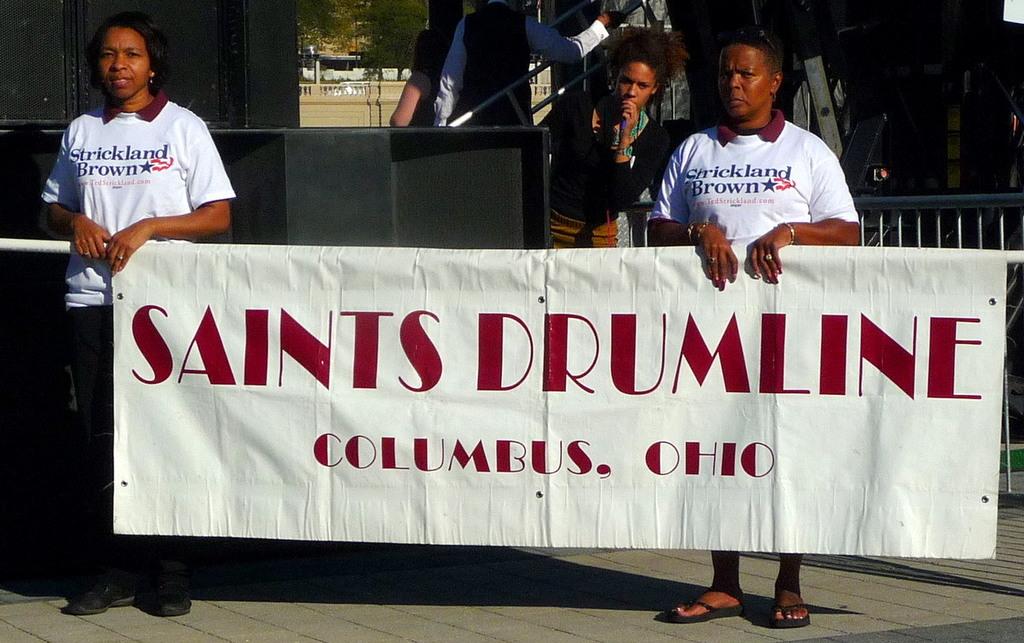What is the name of the drum line?
Provide a short and direct response. Saints. 